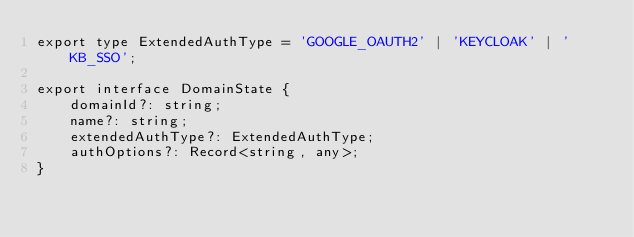Convert code to text. <code><loc_0><loc_0><loc_500><loc_500><_TypeScript_>export type ExtendedAuthType = 'GOOGLE_OAUTH2' | 'KEYCLOAK' | 'KB_SSO';

export interface DomainState {
    domainId?: string;
    name?: string;
    extendedAuthType?: ExtendedAuthType;
    authOptions?: Record<string, any>;
}
</code> 